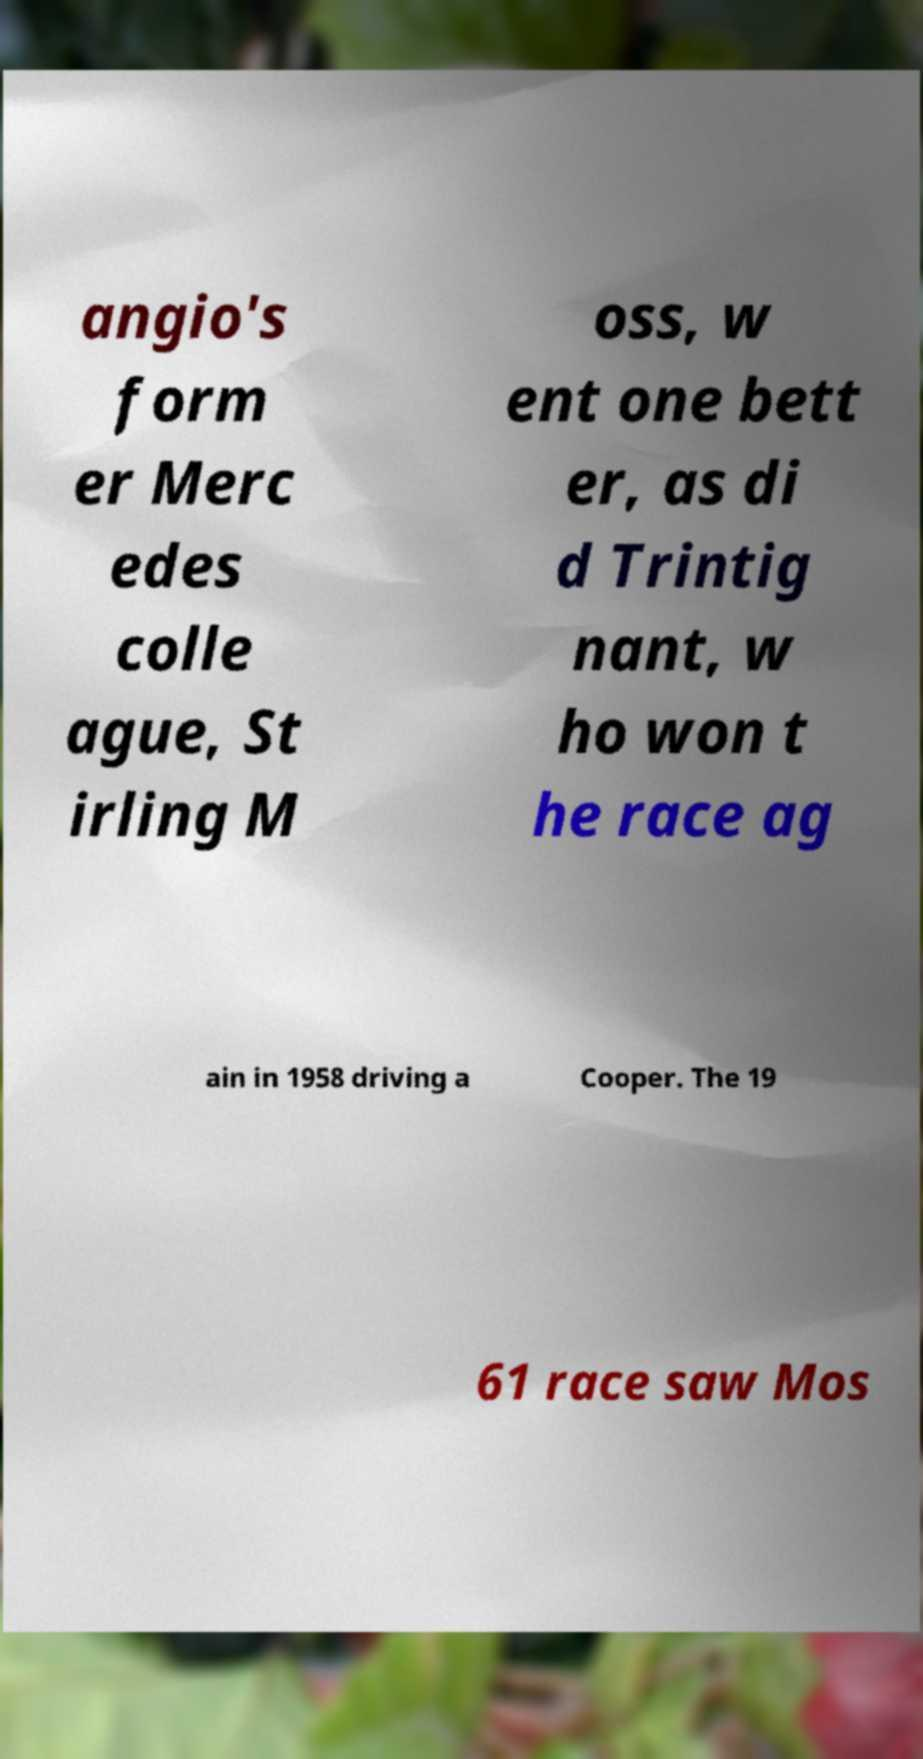Please read and relay the text visible in this image. What does it say? angio's form er Merc edes colle ague, St irling M oss, w ent one bett er, as di d Trintig nant, w ho won t he race ag ain in 1958 driving a Cooper. The 19 61 race saw Mos 